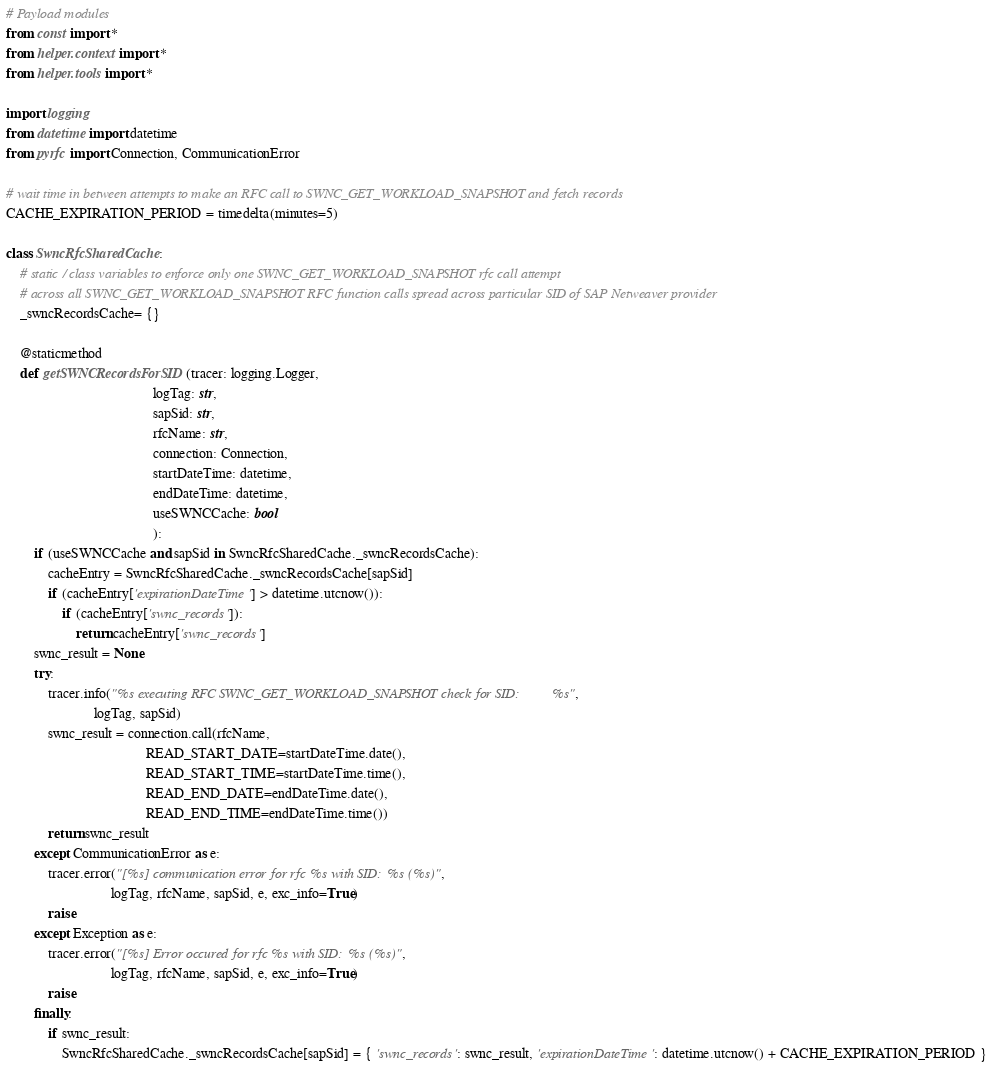<code> <loc_0><loc_0><loc_500><loc_500><_Python_># Payload modules
from const import *
from helper.context import *
from helper.tools import *

import logging
from datetime import datetime
from pyrfc import Connection, CommunicationError

# wait time in between attempts to make an RFC call to SWNC_GET_WORKLOAD_SNAPSHOT and fetch records
CACHE_EXPIRATION_PERIOD = timedelta(minutes=5)

class SwncRfcSharedCache:
    # static / class variables to enforce only one SWNC_GET_WORKLOAD_SNAPSHOT rfc call attempt
    # across all SWNC_GET_WORKLOAD_SNAPSHOT RFC function calls spread across particular SID of SAP Netweaver provider
    _swncRecordsCache= {}

    @staticmethod
    def getSWNCRecordsForSID(tracer: logging.Logger,
                                          logTag: str, 
                                          sapSid: str, 
                                          rfcName: str,
                                          connection: Connection, 
                                          startDateTime: datetime,
                                          endDateTime: datetime,
                                          useSWNCCache: bool
                                          ):
        if (useSWNCCache and sapSid in SwncRfcSharedCache._swncRecordsCache):
            cacheEntry = SwncRfcSharedCache._swncRecordsCache[sapSid]
            if (cacheEntry['expirationDateTime'] > datetime.utcnow()):
                if (cacheEntry['swnc_records']):
                    return cacheEntry['swnc_records']
        swnc_result = None
        try:
            tracer.info("%s executing RFC SWNC_GET_WORKLOAD_SNAPSHOT check for SID: %s",
                         logTag, sapSid)
            swnc_result = connection.call(rfcName, 
                                        READ_START_DATE=startDateTime.date(), 
                                        READ_START_TIME=startDateTime.time(), 
                                        READ_END_DATE=endDateTime.date(), 
                                        READ_END_TIME=endDateTime.time())
            return swnc_result
        except CommunicationError as e:
            tracer.error("[%s] communication error for rfc %s with SID: %s (%s)",
                              logTag, rfcName, sapSid, e, exc_info=True)
            raise
        except Exception as e:
            tracer.error("[%s] Error occured for rfc %s with SID: %s (%s)", 
                              logTag, rfcName, sapSid, e, exc_info=True)
            raise
        finally:
            if swnc_result:
                SwncRfcSharedCache._swncRecordsCache[sapSid] = { 'swnc_records': swnc_result, 'expirationDateTime': datetime.utcnow() + CACHE_EXPIRATION_PERIOD }</code> 